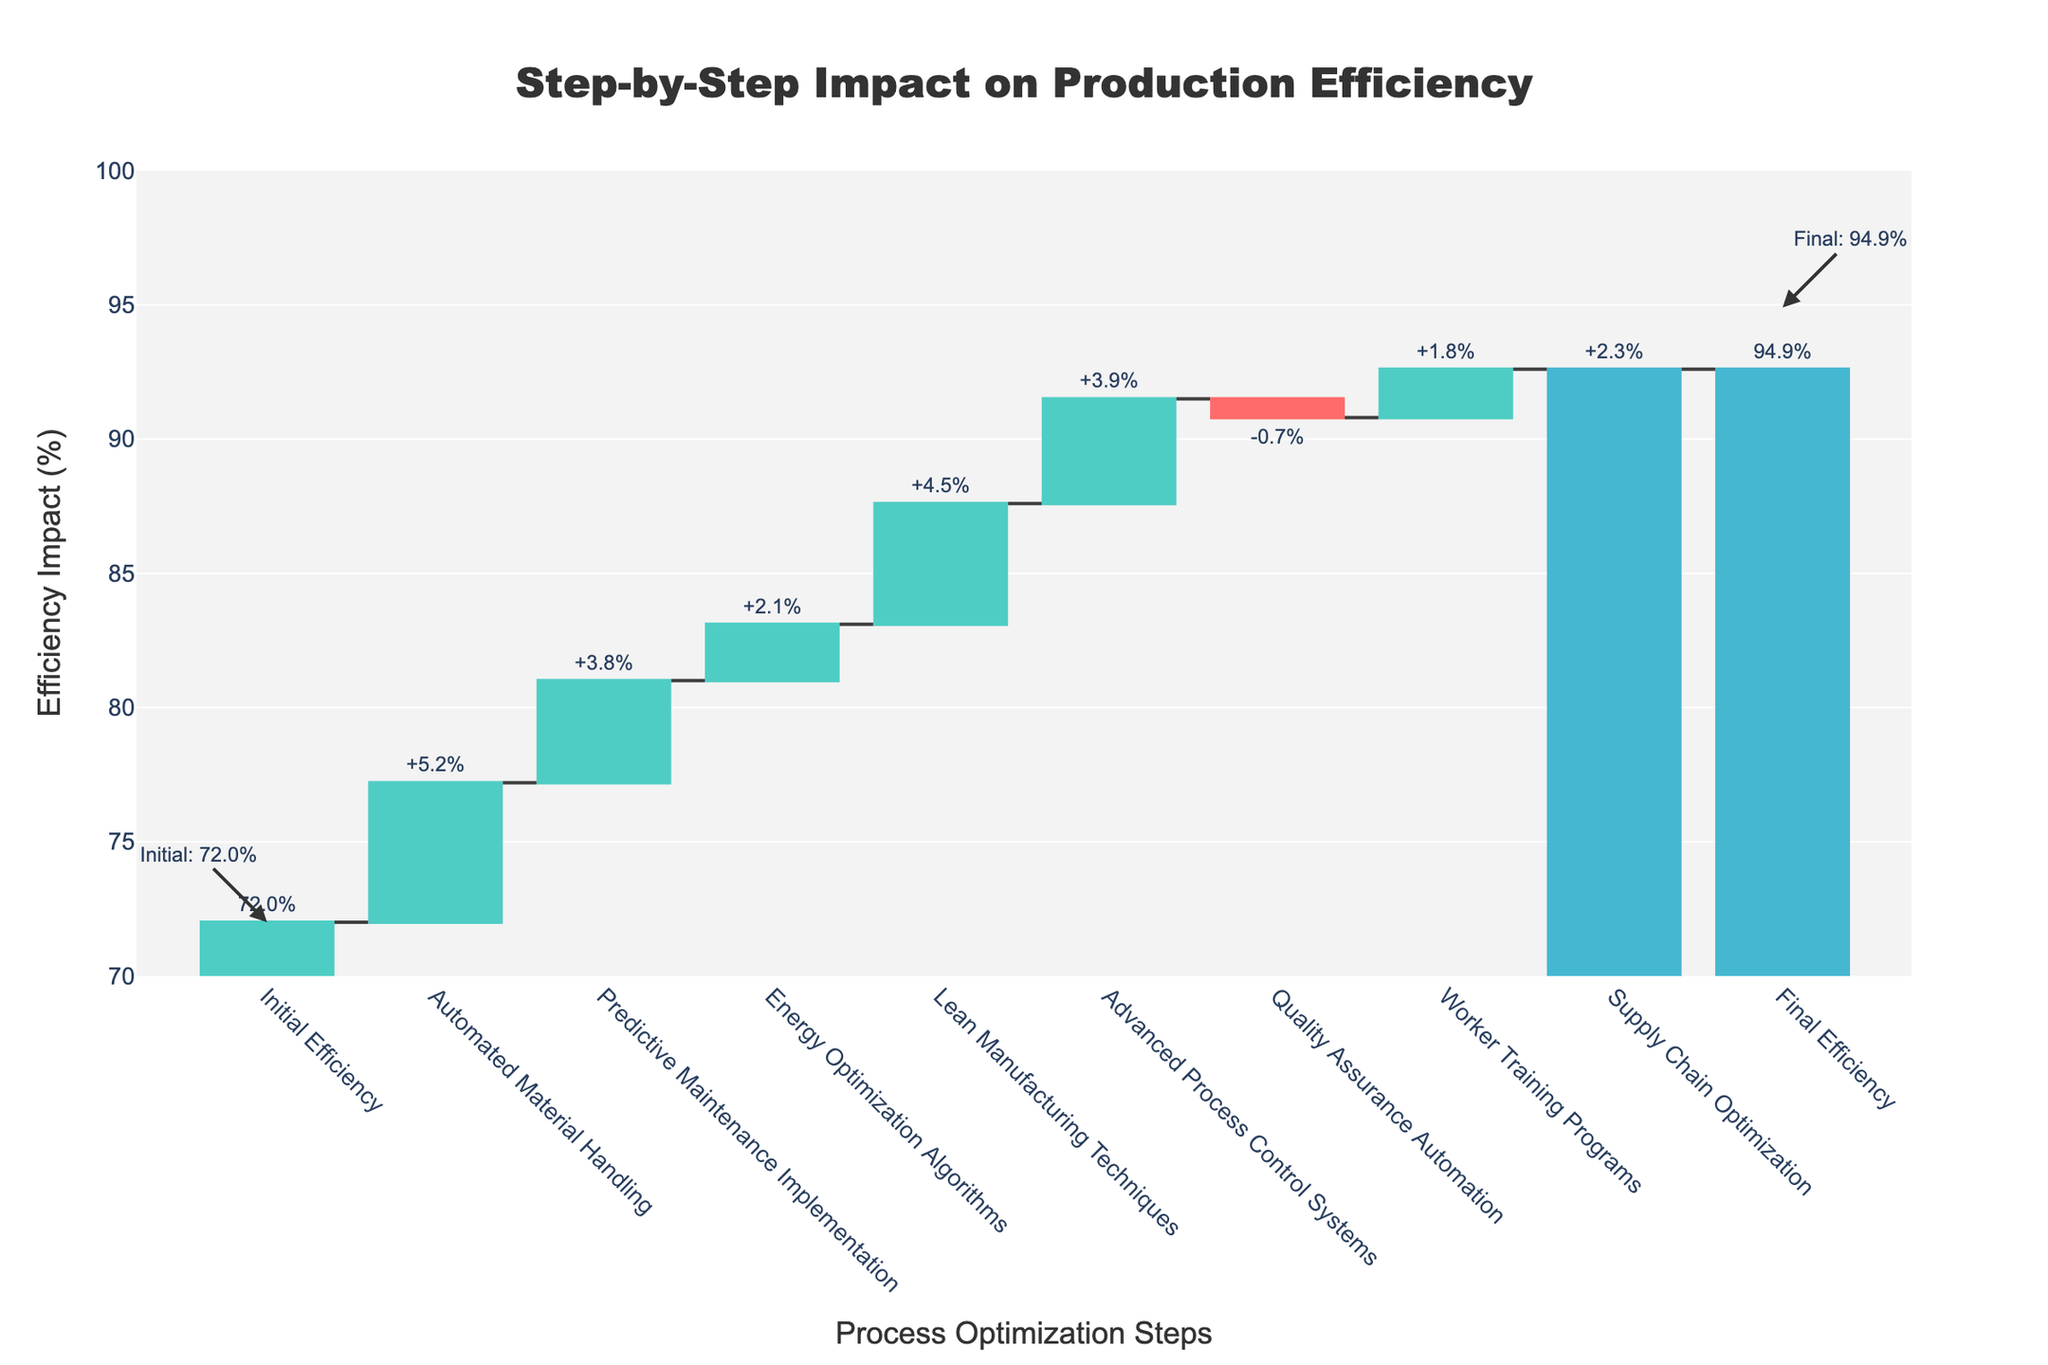What is the title of the chart? The title is found at the top of the chart.
Answer: Step-by-Step Impact on Production Efficiency What color is used for decreasing impacts? The color commonly used for decreasing impacts is red.
Answer: Red Is the final efficiency higher or lower than the initial efficiency? Compare the final value to the initial value.
Answer: Higher What was the impact of Quality Assurance Automation? Find the step labeled "Quality Assurance Automation" on the x-axis and note the impact value.
Answer: -0.7% How many optimization steps are there excluding the initial and final efficiencies? Count the steps between the initial and final efficiency.
Answer: 8 What is the combined impact of Automated Material Handling and Lean Manufacturing Techniques? Add the impacts of both steps.
Answer: 5.2% + 4.5% = 9.7% Which step had the highest positive impact on production efficiency? Identify the step with the largest positive impact value.
Answer: Automated Material Handling What is the sum of all the positive impacts? Add the values of all steps with positive impacts: 5.2 + 3.8 + 2.1 + 4.5 + 3.9 + 1.8 + 2.3.
Answer: 23.6% How much did the efficiency improve after implementing Advanced Process Control Systems? Find the step labeled "Advanced Process Control Systems" and note the impact.
Answer: 3.9% What is the net impact of all steps combined? Subtract the negative impacts from the sum of positive impacts.
Answer: 23.6% - 0.7% = 22.9% 